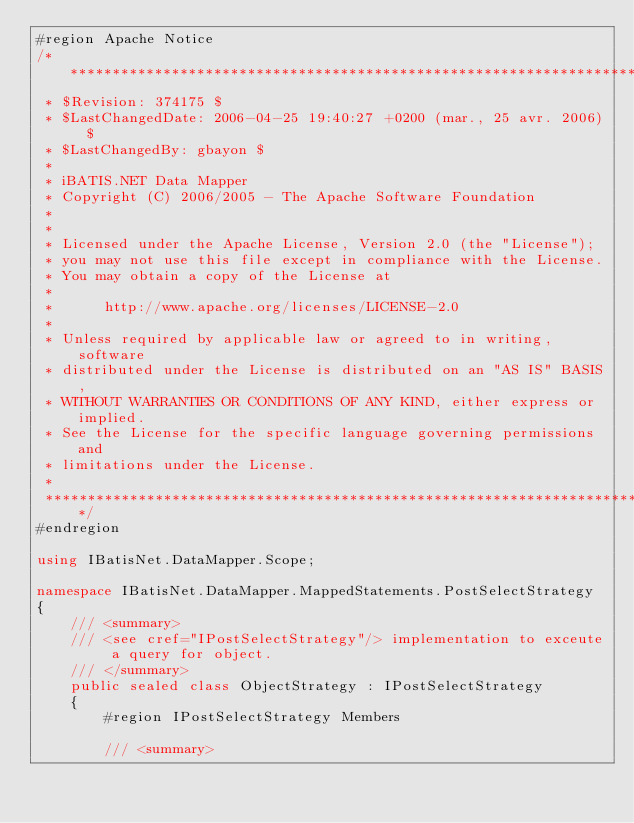<code> <loc_0><loc_0><loc_500><loc_500><_C#_>#region Apache Notice
/*****************************************************************************
 * $Revision: 374175 $
 * $LastChangedDate: 2006-04-25 19:40:27 +0200 (mar., 25 avr. 2006) $
 * $LastChangedBy: gbayon $
 *
 * iBATIS.NET Data Mapper
 * Copyright (C) 2006/2005 - The Apache Software Foundation
 *
 *
 * Licensed under the Apache License, Version 2.0 (the "License");
 * you may not use this file except in compliance with the License.
 * You may obtain a copy of the License at
 *
 *      http://www.apache.org/licenses/LICENSE-2.0
 *
 * Unless required by applicable law or agreed to in writing, software
 * distributed under the License is distributed on an "AS IS" BASIS,
 * WITHOUT WARRANTIES OR CONDITIONS OF ANY KIND, either express or implied.
 * See the License for the specific language governing permissions and
 * limitations under the License.
 *
 ********************************************************************************/
#endregion

using IBatisNet.DataMapper.Scope;

namespace IBatisNet.DataMapper.MappedStatements.PostSelectStrategy
{
    /// <summary>
    /// <see cref="IPostSelectStrategy"/> implementation to exceute a query for object.
    /// </summary>
    public sealed class ObjectStrategy : IPostSelectStrategy
    {
        #region IPostSelectStrategy Members

        /// <summary></code> 